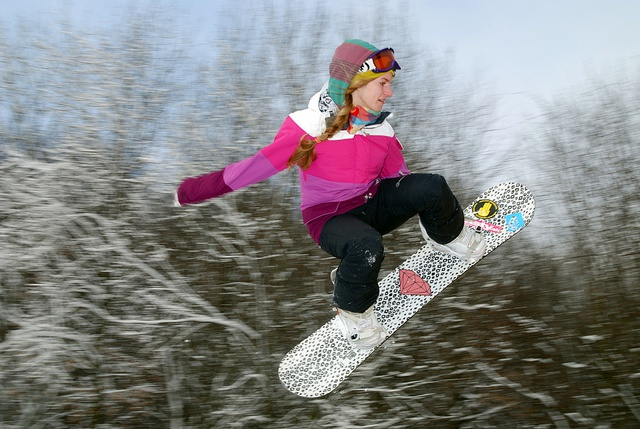Describe the objects in this image and their specific colors. I can see people in lightblue, black, lightgray, magenta, and brown tones and snowboard in lightblue, lightgray, darkgray, gray, and black tones in this image. 